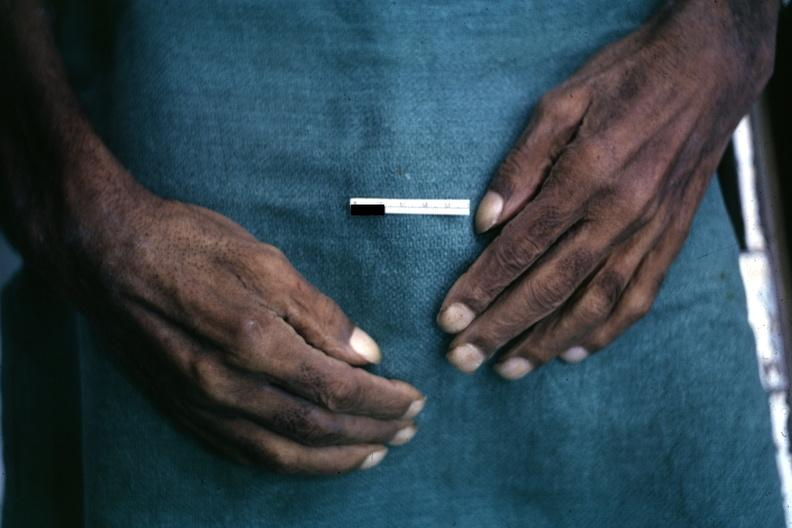what is present?
Answer the question using a single word or phrase. Hand 